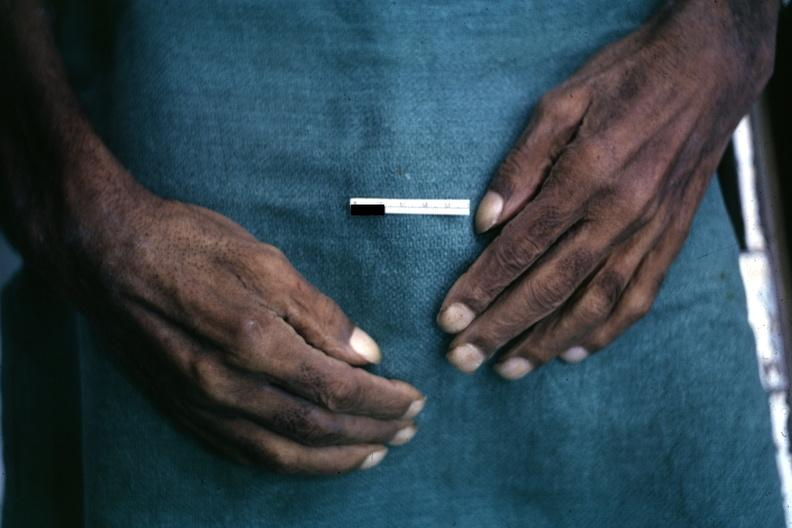what is present?
Answer the question using a single word or phrase. Hand 